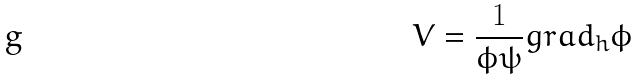Convert formula to latex. <formula><loc_0><loc_0><loc_500><loc_500>V = \frac { 1 } { \phi \psi } g r a d _ { h } \phi</formula> 